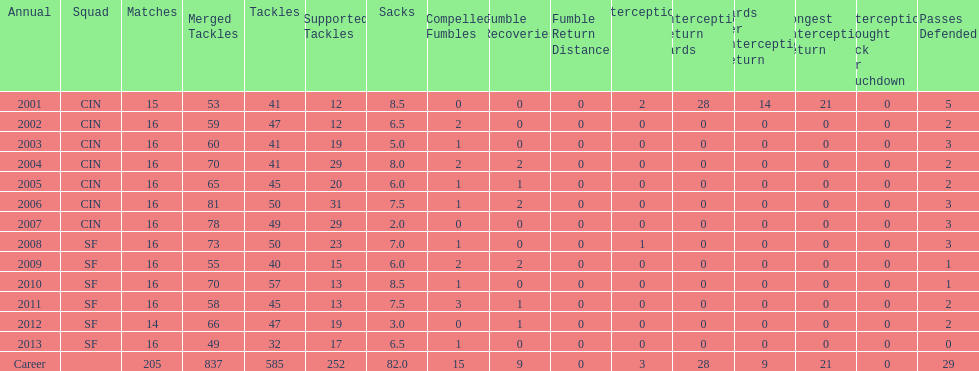How many years did he play where he did not recover a fumble? 7. 